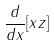Convert formula to latex. <formula><loc_0><loc_0><loc_500><loc_500>\frac { d } { d x } [ x z ]</formula> 